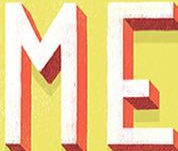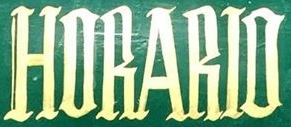Read the text from these images in sequence, separated by a semicolon. ME; HORARIO 